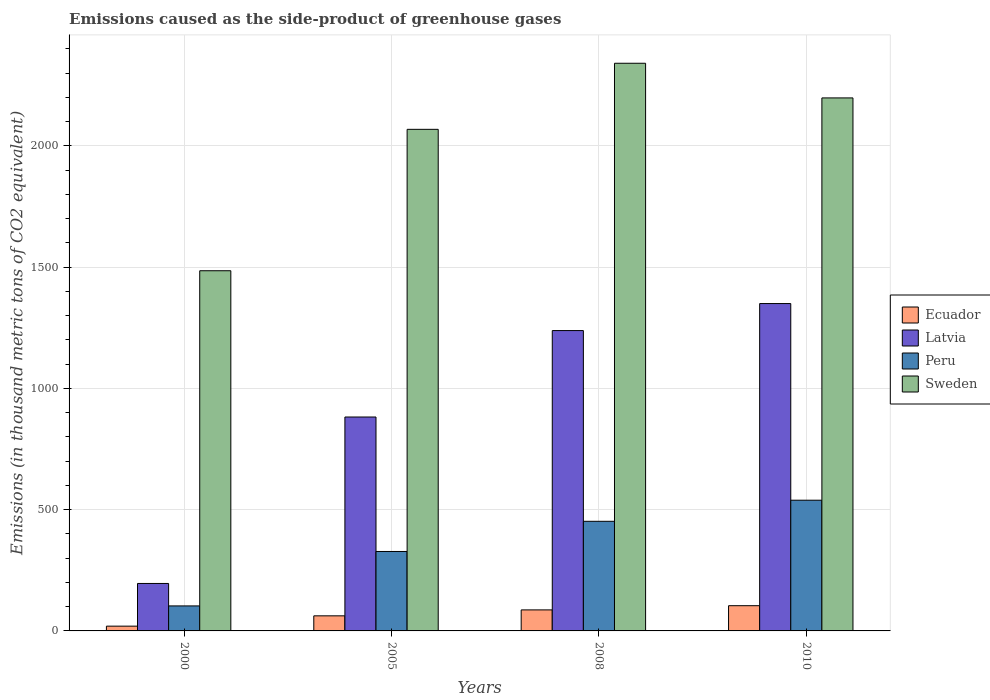How many groups of bars are there?
Make the answer very short. 4. How many bars are there on the 1st tick from the left?
Your response must be concise. 4. How many bars are there on the 4th tick from the right?
Make the answer very short. 4. What is the emissions caused as the side-product of greenhouse gases in Sweden in 2000?
Keep it short and to the point. 1485.3. Across all years, what is the maximum emissions caused as the side-product of greenhouse gases in Ecuador?
Give a very brief answer. 104. In which year was the emissions caused as the side-product of greenhouse gases in Sweden maximum?
Your answer should be very brief. 2008. In which year was the emissions caused as the side-product of greenhouse gases in Latvia minimum?
Provide a succinct answer. 2000. What is the total emissions caused as the side-product of greenhouse gases in Ecuador in the graph?
Keep it short and to the point. 272.6. What is the difference between the emissions caused as the side-product of greenhouse gases in Ecuador in 2008 and that in 2010?
Provide a succinct answer. -17.3. What is the difference between the emissions caused as the side-product of greenhouse gases in Latvia in 2008 and the emissions caused as the side-product of greenhouse gases in Peru in 2010?
Ensure brevity in your answer.  699.6. What is the average emissions caused as the side-product of greenhouse gases in Latvia per year?
Provide a short and direct response. 916.6. In the year 2005, what is the difference between the emissions caused as the side-product of greenhouse gases in Ecuador and emissions caused as the side-product of greenhouse gases in Latvia?
Provide a short and direct response. -819.9. What is the ratio of the emissions caused as the side-product of greenhouse gases in Ecuador in 2000 to that in 2010?
Provide a short and direct response. 0.19. Is the emissions caused as the side-product of greenhouse gases in Sweden in 2000 less than that in 2010?
Provide a short and direct response. Yes. What is the difference between the highest and the second highest emissions caused as the side-product of greenhouse gases in Peru?
Offer a terse response. 87. What is the difference between the highest and the lowest emissions caused as the side-product of greenhouse gases in Sweden?
Your response must be concise. 855.6. What does the 1st bar from the left in 2008 represents?
Your answer should be compact. Ecuador. What does the 1st bar from the right in 2005 represents?
Offer a terse response. Sweden. How many bars are there?
Your answer should be very brief. 16. What is the difference between two consecutive major ticks on the Y-axis?
Offer a very short reply. 500. Does the graph contain any zero values?
Your answer should be compact. No. What is the title of the graph?
Your answer should be very brief. Emissions caused as the side-product of greenhouse gases. Does "Trinidad and Tobago" appear as one of the legend labels in the graph?
Your response must be concise. No. What is the label or title of the X-axis?
Offer a terse response. Years. What is the label or title of the Y-axis?
Give a very brief answer. Emissions (in thousand metric tons of CO2 equivalent). What is the Emissions (in thousand metric tons of CO2 equivalent) in Latvia in 2000?
Offer a very short reply. 195.7. What is the Emissions (in thousand metric tons of CO2 equivalent) of Peru in 2000?
Ensure brevity in your answer.  103.1. What is the Emissions (in thousand metric tons of CO2 equivalent) of Sweden in 2000?
Keep it short and to the point. 1485.3. What is the Emissions (in thousand metric tons of CO2 equivalent) of Ecuador in 2005?
Your answer should be very brief. 62.2. What is the Emissions (in thousand metric tons of CO2 equivalent) of Latvia in 2005?
Offer a very short reply. 882.1. What is the Emissions (in thousand metric tons of CO2 equivalent) in Peru in 2005?
Give a very brief answer. 327.6. What is the Emissions (in thousand metric tons of CO2 equivalent) of Sweden in 2005?
Make the answer very short. 2068.4. What is the Emissions (in thousand metric tons of CO2 equivalent) of Ecuador in 2008?
Make the answer very short. 86.7. What is the Emissions (in thousand metric tons of CO2 equivalent) of Latvia in 2008?
Ensure brevity in your answer.  1238.6. What is the Emissions (in thousand metric tons of CO2 equivalent) in Peru in 2008?
Keep it short and to the point. 452. What is the Emissions (in thousand metric tons of CO2 equivalent) in Sweden in 2008?
Make the answer very short. 2340.9. What is the Emissions (in thousand metric tons of CO2 equivalent) in Ecuador in 2010?
Your answer should be compact. 104. What is the Emissions (in thousand metric tons of CO2 equivalent) of Latvia in 2010?
Offer a terse response. 1350. What is the Emissions (in thousand metric tons of CO2 equivalent) of Peru in 2010?
Your answer should be compact. 539. What is the Emissions (in thousand metric tons of CO2 equivalent) in Sweden in 2010?
Provide a short and direct response. 2198. Across all years, what is the maximum Emissions (in thousand metric tons of CO2 equivalent) of Ecuador?
Your answer should be very brief. 104. Across all years, what is the maximum Emissions (in thousand metric tons of CO2 equivalent) in Latvia?
Ensure brevity in your answer.  1350. Across all years, what is the maximum Emissions (in thousand metric tons of CO2 equivalent) in Peru?
Offer a very short reply. 539. Across all years, what is the maximum Emissions (in thousand metric tons of CO2 equivalent) of Sweden?
Ensure brevity in your answer.  2340.9. Across all years, what is the minimum Emissions (in thousand metric tons of CO2 equivalent) in Ecuador?
Your response must be concise. 19.7. Across all years, what is the minimum Emissions (in thousand metric tons of CO2 equivalent) in Latvia?
Keep it short and to the point. 195.7. Across all years, what is the minimum Emissions (in thousand metric tons of CO2 equivalent) of Peru?
Provide a succinct answer. 103.1. Across all years, what is the minimum Emissions (in thousand metric tons of CO2 equivalent) in Sweden?
Provide a succinct answer. 1485.3. What is the total Emissions (in thousand metric tons of CO2 equivalent) in Ecuador in the graph?
Offer a very short reply. 272.6. What is the total Emissions (in thousand metric tons of CO2 equivalent) in Latvia in the graph?
Give a very brief answer. 3666.4. What is the total Emissions (in thousand metric tons of CO2 equivalent) of Peru in the graph?
Offer a very short reply. 1421.7. What is the total Emissions (in thousand metric tons of CO2 equivalent) in Sweden in the graph?
Ensure brevity in your answer.  8092.6. What is the difference between the Emissions (in thousand metric tons of CO2 equivalent) in Ecuador in 2000 and that in 2005?
Keep it short and to the point. -42.5. What is the difference between the Emissions (in thousand metric tons of CO2 equivalent) in Latvia in 2000 and that in 2005?
Offer a terse response. -686.4. What is the difference between the Emissions (in thousand metric tons of CO2 equivalent) of Peru in 2000 and that in 2005?
Offer a terse response. -224.5. What is the difference between the Emissions (in thousand metric tons of CO2 equivalent) of Sweden in 2000 and that in 2005?
Provide a succinct answer. -583.1. What is the difference between the Emissions (in thousand metric tons of CO2 equivalent) of Ecuador in 2000 and that in 2008?
Ensure brevity in your answer.  -67. What is the difference between the Emissions (in thousand metric tons of CO2 equivalent) of Latvia in 2000 and that in 2008?
Offer a terse response. -1042.9. What is the difference between the Emissions (in thousand metric tons of CO2 equivalent) of Peru in 2000 and that in 2008?
Your response must be concise. -348.9. What is the difference between the Emissions (in thousand metric tons of CO2 equivalent) in Sweden in 2000 and that in 2008?
Your answer should be very brief. -855.6. What is the difference between the Emissions (in thousand metric tons of CO2 equivalent) of Ecuador in 2000 and that in 2010?
Offer a terse response. -84.3. What is the difference between the Emissions (in thousand metric tons of CO2 equivalent) in Latvia in 2000 and that in 2010?
Make the answer very short. -1154.3. What is the difference between the Emissions (in thousand metric tons of CO2 equivalent) in Peru in 2000 and that in 2010?
Ensure brevity in your answer.  -435.9. What is the difference between the Emissions (in thousand metric tons of CO2 equivalent) of Sweden in 2000 and that in 2010?
Ensure brevity in your answer.  -712.7. What is the difference between the Emissions (in thousand metric tons of CO2 equivalent) in Ecuador in 2005 and that in 2008?
Give a very brief answer. -24.5. What is the difference between the Emissions (in thousand metric tons of CO2 equivalent) in Latvia in 2005 and that in 2008?
Provide a succinct answer. -356.5. What is the difference between the Emissions (in thousand metric tons of CO2 equivalent) of Peru in 2005 and that in 2008?
Keep it short and to the point. -124.4. What is the difference between the Emissions (in thousand metric tons of CO2 equivalent) in Sweden in 2005 and that in 2008?
Make the answer very short. -272.5. What is the difference between the Emissions (in thousand metric tons of CO2 equivalent) of Ecuador in 2005 and that in 2010?
Provide a short and direct response. -41.8. What is the difference between the Emissions (in thousand metric tons of CO2 equivalent) of Latvia in 2005 and that in 2010?
Give a very brief answer. -467.9. What is the difference between the Emissions (in thousand metric tons of CO2 equivalent) of Peru in 2005 and that in 2010?
Keep it short and to the point. -211.4. What is the difference between the Emissions (in thousand metric tons of CO2 equivalent) in Sweden in 2005 and that in 2010?
Ensure brevity in your answer.  -129.6. What is the difference between the Emissions (in thousand metric tons of CO2 equivalent) in Ecuador in 2008 and that in 2010?
Offer a very short reply. -17.3. What is the difference between the Emissions (in thousand metric tons of CO2 equivalent) in Latvia in 2008 and that in 2010?
Offer a very short reply. -111.4. What is the difference between the Emissions (in thousand metric tons of CO2 equivalent) of Peru in 2008 and that in 2010?
Keep it short and to the point. -87. What is the difference between the Emissions (in thousand metric tons of CO2 equivalent) in Sweden in 2008 and that in 2010?
Keep it short and to the point. 142.9. What is the difference between the Emissions (in thousand metric tons of CO2 equivalent) in Ecuador in 2000 and the Emissions (in thousand metric tons of CO2 equivalent) in Latvia in 2005?
Your answer should be very brief. -862.4. What is the difference between the Emissions (in thousand metric tons of CO2 equivalent) of Ecuador in 2000 and the Emissions (in thousand metric tons of CO2 equivalent) of Peru in 2005?
Keep it short and to the point. -307.9. What is the difference between the Emissions (in thousand metric tons of CO2 equivalent) in Ecuador in 2000 and the Emissions (in thousand metric tons of CO2 equivalent) in Sweden in 2005?
Give a very brief answer. -2048.7. What is the difference between the Emissions (in thousand metric tons of CO2 equivalent) of Latvia in 2000 and the Emissions (in thousand metric tons of CO2 equivalent) of Peru in 2005?
Ensure brevity in your answer.  -131.9. What is the difference between the Emissions (in thousand metric tons of CO2 equivalent) of Latvia in 2000 and the Emissions (in thousand metric tons of CO2 equivalent) of Sweden in 2005?
Offer a very short reply. -1872.7. What is the difference between the Emissions (in thousand metric tons of CO2 equivalent) of Peru in 2000 and the Emissions (in thousand metric tons of CO2 equivalent) of Sweden in 2005?
Provide a succinct answer. -1965.3. What is the difference between the Emissions (in thousand metric tons of CO2 equivalent) in Ecuador in 2000 and the Emissions (in thousand metric tons of CO2 equivalent) in Latvia in 2008?
Your response must be concise. -1218.9. What is the difference between the Emissions (in thousand metric tons of CO2 equivalent) of Ecuador in 2000 and the Emissions (in thousand metric tons of CO2 equivalent) of Peru in 2008?
Provide a succinct answer. -432.3. What is the difference between the Emissions (in thousand metric tons of CO2 equivalent) in Ecuador in 2000 and the Emissions (in thousand metric tons of CO2 equivalent) in Sweden in 2008?
Provide a short and direct response. -2321.2. What is the difference between the Emissions (in thousand metric tons of CO2 equivalent) of Latvia in 2000 and the Emissions (in thousand metric tons of CO2 equivalent) of Peru in 2008?
Offer a terse response. -256.3. What is the difference between the Emissions (in thousand metric tons of CO2 equivalent) in Latvia in 2000 and the Emissions (in thousand metric tons of CO2 equivalent) in Sweden in 2008?
Keep it short and to the point. -2145.2. What is the difference between the Emissions (in thousand metric tons of CO2 equivalent) in Peru in 2000 and the Emissions (in thousand metric tons of CO2 equivalent) in Sweden in 2008?
Provide a succinct answer. -2237.8. What is the difference between the Emissions (in thousand metric tons of CO2 equivalent) in Ecuador in 2000 and the Emissions (in thousand metric tons of CO2 equivalent) in Latvia in 2010?
Your answer should be very brief. -1330.3. What is the difference between the Emissions (in thousand metric tons of CO2 equivalent) of Ecuador in 2000 and the Emissions (in thousand metric tons of CO2 equivalent) of Peru in 2010?
Give a very brief answer. -519.3. What is the difference between the Emissions (in thousand metric tons of CO2 equivalent) of Ecuador in 2000 and the Emissions (in thousand metric tons of CO2 equivalent) of Sweden in 2010?
Give a very brief answer. -2178.3. What is the difference between the Emissions (in thousand metric tons of CO2 equivalent) in Latvia in 2000 and the Emissions (in thousand metric tons of CO2 equivalent) in Peru in 2010?
Your answer should be very brief. -343.3. What is the difference between the Emissions (in thousand metric tons of CO2 equivalent) in Latvia in 2000 and the Emissions (in thousand metric tons of CO2 equivalent) in Sweden in 2010?
Keep it short and to the point. -2002.3. What is the difference between the Emissions (in thousand metric tons of CO2 equivalent) in Peru in 2000 and the Emissions (in thousand metric tons of CO2 equivalent) in Sweden in 2010?
Provide a succinct answer. -2094.9. What is the difference between the Emissions (in thousand metric tons of CO2 equivalent) of Ecuador in 2005 and the Emissions (in thousand metric tons of CO2 equivalent) of Latvia in 2008?
Your response must be concise. -1176.4. What is the difference between the Emissions (in thousand metric tons of CO2 equivalent) in Ecuador in 2005 and the Emissions (in thousand metric tons of CO2 equivalent) in Peru in 2008?
Your answer should be very brief. -389.8. What is the difference between the Emissions (in thousand metric tons of CO2 equivalent) of Ecuador in 2005 and the Emissions (in thousand metric tons of CO2 equivalent) of Sweden in 2008?
Offer a very short reply. -2278.7. What is the difference between the Emissions (in thousand metric tons of CO2 equivalent) of Latvia in 2005 and the Emissions (in thousand metric tons of CO2 equivalent) of Peru in 2008?
Provide a succinct answer. 430.1. What is the difference between the Emissions (in thousand metric tons of CO2 equivalent) in Latvia in 2005 and the Emissions (in thousand metric tons of CO2 equivalent) in Sweden in 2008?
Your response must be concise. -1458.8. What is the difference between the Emissions (in thousand metric tons of CO2 equivalent) in Peru in 2005 and the Emissions (in thousand metric tons of CO2 equivalent) in Sweden in 2008?
Give a very brief answer. -2013.3. What is the difference between the Emissions (in thousand metric tons of CO2 equivalent) in Ecuador in 2005 and the Emissions (in thousand metric tons of CO2 equivalent) in Latvia in 2010?
Keep it short and to the point. -1287.8. What is the difference between the Emissions (in thousand metric tons of CO2 equivalent) of Ecuador in 2005 and the Emissions (in thousand metric tons of CO2 equivalent) of Peru in 2010?
Provide a succinct answer. -476.8. What is the difference between the Emissions (in thousand metric tons of CO2 equivalent) in Ecuador in 2005 and the Emissions (in thousand metric tons of CO2 equivalent) in Sweden in 2010?
Your answer should be very brief. -2135.8. What is the difference between the Emissions (in thousand metric tons of CO2 equivalent) in Latvia in 2005 and the Emissions (in thousand metric tons of CO2 equivalent) in Peru in 2010?
Keep it short and to the point. 343.1. What is the difference between the Emissions (in thousand metric tons of CO2 equivalent) in Latvia in 2005 and the Emissions (in thousand metric tons of CO2 equivalent) in Sweden in 2010?
Your answer should be very brief. -1315.9. What is the difference between the Emissions (in thousand metric tons of CO2 equivalent) in Peru in 2005 and the Emissions (in thousand metric tons of CO2 equivalent) in Sweden in 2010?
Your answer should be compact. -1870.4. What is the difference between the Emissions (in thousand metric tons of CO2 equivalent) of Ecuador in 2008 and the Emissions (in thousand metric tons of CO2 equivalent) of Latvia in 2010?
Offer a very short reply. -1263.3. What is the difference between the Emissions (in thousand metric tons of CO2 equivalent) in Ecuador in 2008 and the Emissions (in thousand metric tons of CO2 equivalent) in Peru in 2010?
Ensure brevity in your answer.  -452.3. What is the difference between the Emissions (in thousand metric tons of CO2 equivalent) in Ecuador in 2008 and the Emissions (in thousand metric tons of CO2 equivalent) in Sweden in 2010?
Your answer should be very brief. -2111.3. What is the difference between the Emissions (in thousand metric tons of CO2 equivalent) of Latvia in 2008 and the Emissions (in thousand metric tons of CO2 equivalent) of Peru in 2010?
Keep it short and to the point. 699.6. What is the difference between the Emissions (in thousand metric tons of CO2 equivalent) in Latvia in 2008 and the Emissions (in thousand metric tons of CO2 equivalent) in Sweden in 2010?
Offer a very short reply. -959.4. What is the difference between the Emissions (in thousand metric tons of CO2 equivalent) of Peru in 2008 and the Emissions (in thousand metric tons of CO2 equivalent) of Sweden in 2010?
Your response must be concise. -1746. What is the average Emissions (in thousand metric tons of CO2 equivalent) in Ecuador per year?
Give a very brief answer. 68.15. What is the average Emissions (in thousand metric tons of CO2 equivalent) of Latvia per year?
Ensure brevity in your answer.  916.6. What is the average Emissions (in thousand metric tons of CO2 equivalent) in Peru per year?
Provide a short and direct response. 355.43. What is the average Emissions (in thousand metric tons of CO2 equivalent) of Sweden per year?
Ensure brevity in your answer.  2023.15. In the year 2000, what is the difference between the Emissions (in thousand metric tons of CO2 equivalent) of Ecuador and Emissions (in thousand metric tons of CO2 equivalent) of Latvia?
Provide a succinct answer. -176. In the year 2000, what is the difference between the Emissions (in thousand metric tons of CO2 equivalent) of Ecuador and Emissions (in thousand metric tons of CO2 equivalent) of Peru?
Your answer should be compact. -83.4. In the year 2000, what is the difference between the Emissions (in thousand metric tons of CO2 equivalent) of Ecuador and Emissions (in thousand metric tons of CO2 equivalent) of Sweden?
Your answer should be compact. -1465.6. In the year 2000, what is the difference between the Emissions (in thousand metric tons of CO2 equivalent) in Latvia and Emissions (in thousand metric tons of CO2 equivalent) in Peru?
Your answer should be very brief. 92.6. In the year 2000, what is the difference between the Emissions (in thousand metric tons of CO2 equivalent) of Latvia and Emissions (in thousand metric tons of CO2 equivalent) of Sweden?
Make the answer very short. -1289.6. In the year 2000, what is the difference between the Emissions (in thousand metric tons of CO2 equivalent) in Peru and Emissions (in thousand metric tons of CO2 equivalent) in Sweden?
Make the answer very short. -1382.2. In the year 2005, what is the difference between the Emissions (in thousand metric tons of CO2 equivalent) in Ecuador and Emissions (in thousand metric tons of CO2 equivalent) in Latvia?
Offer a terse response. -819.9. In the year 2005, what is the difference between the Emissions (in thousand metric tons of CO2 equivalent) in Ecuador and Emissions (in thousand metric tons of CO2 equivalent) in Peru?
Make the answer very short. -265.4. In the year 2005, what is the difference between the Emissions (in thousand metric tons of CO2 equivalent) in Ecuador and Emissions (in thousand metric tons of CO2 equivalent) in Sweden?
Your answer should be compact. -2006.2. In the year 2005, what is the difference between the Emissions (in thousand metric tons of CO2 equivalent) of Latvia and Emissions (in thousand metric tons of CO2 equivalent) of Peru?
Your response must be concise. 554.5. In the year 2005, what is the difference between the Emissions (in thousand metric tons of CO2 equivalent) in Latvia and Emissions (in thousand metric tons of CO2 equivalent) in Sweden?
Make the answer very short. -1186.3. In the year 2005, what is the difference between the Emissions (in thousand metric tons of CO2 equivalent) of Peru and Emissions (in thousand metric tons of CO2 equivalent) of Sweden?
Provide a succinct answer. -1740.8. In the year 2008, what is the difference between the Emissions (in thousand metric tons of CO2 equivalent) in Ecuador and Emissions (in thousand metric tons of CO2 equivalent) in Latvia?
Offer a very short reply. -1151.9. In the year 2008, what is the difference between the Emissions (in thousand metric tons of CO2 equivalent) of Ecuador and Emissions (in thousand metric tons of CO2 equivalent) of Peru?
Your answer should be very brief. -365.3. In the year 2008, what is the difference between the Emissions (in thousand metric tons of CO2 equivalent) of Ecuador and Emissions (in thousand metric tons of CO2 equivalent) of Sweden?
Ensure brevity in your answer.  -2254.2. In the year 2008, what is the difference between the Emissions (in thousand metric tons of CO2 equivalent) in Latvia and Emissions (in thousand metric tons of CO2 equivalent) in Peru?
Provide a succinct answer. 786.6. In the year 2008, what is the difference between the Emissions (in thousand metric tons of CO2 equivalent) of Latvia and Emissions (in thousand metric tons of CO2 equivalent) of Sweden?
Provide a short and direct response. -1102.3. In the year 2008, what is the difference between the Emissions (in thousand metric tons of CO2 equivalent) of Peru and Emissions (in thousand metric tons of CO2 equivalent) of Sweden?
Provide a succinct answer. -1888.9. In the year 2010, what is the difference between the Emissions (in thousand metric tons of CO2 equivalent) of Ecuador and Emissions (in thousand metric tons of CO2 equivalent) of Latvia?
Your answer should be compact. -1246. In the year 2010, what is the difference between the Emissions (in thousand metric tons of CO2 equivalent) of Ecuador and Emissions (in thousand metric tons of CO2 equivalent) of Peru?
Your answer should be very brief. -435. In the year 2010, what is the difference between the Emissions (in thousand metric tons of CO2 equivalent) in Ecuador and Emissions (in thousand metric tons of CO2 equivalent) in Sweden?
Offer a terse response. -2094. In the year 2010, what is the difference between the Emissions (in thousand metric tons of CO2 equivalent) in Latvia and Emissions (in thousand metric tons of CO2 equivalent) in Peru?
Your response must be concise. 811. In the year 2010, what is the difference between the Emissions (in thousand metric tons of CO2 equivalent) of Latvia and Emissions (in thousand metric tons of CO2 equivalent) of Sweden?
Your answer should be very brief. -848. In the year 2010, what is the difference between the Emissions (in thousand metric tons of CO2 equivalent) of Peru and Emissions (in thousand metric tons of CO2 equivalent) of Sweden?
Offer a terse response. -1659. What is the ratio of the Emissions (in thousand metric tons of CO2 equivalent) of Ecuador in 2000 to that in 2005?
Provide a short and direct response. 0.32. What is the ratio of the Emissions (in thousand metric tons of CO2 equivalent) in Latvia in 2000 to that in 2005?
Ensure brevity in your answer.  0.22. What is the ratio of the Emissions (in thousand metric tons of CO2 equivalent) of Peru in 2000 to that in 2005?
Provide a short and direct response. 0.31. What is the ratio of the Emissions (in thousand metric tons of CO2 equivalent) of Sweden in 2000 to that in 2005?
Provide a succinct answer. 0.72. What is the ratio of the Emissions (in thousand metric tons of CO2 equivalent) of Ecuador in 2000 to that in 2008?
Ensure brevity in your answer.  0.23. What is the ratio of the Emissions (in thousand metric tons of CO2 equivalent) in Latvia in 2000 to that in 2008?
Give a very brief answer. 0.16. What is the ratio of the Emissions (in thousand metric tons of CO2 equivalent) of Peru in 2000 to that in 2008?
Provide a short and direct response. 0.23. What is the ratio of the Emissions (in thousand metric tons of CO2 equivalent) in Sweden in 2000 to that in 2008?
Your answer should be very brief. 0.63. What is the ratio of the Emissions (in thousand metric tons of CO2 equivalent) of Ecuador in 2000 to that in 2010?
Offer a terse response. 0.19. What is the ratio of the Emissions (in thousand metric tons of CO2 equivalent) in Latvia in 2000 to that in 2010?
Keep it short and to the point. 0.14. What is the ratio of the Emissions (in thousand metric tons of CO2 equivalent) in Peru in 2000 to that in 2010?
Provide a succinct answer. 0.19. What is the ratio of the Emissions (in thousand metric tons of CO2 equivalent) of Sweden in 2000 to that in 2010?
Keep it short and to the point. 0.68. What is the ratio of the Emissions (in thousand metric tons of CO2 equivalent) of Ecuador in 2005 to that in 2008?
Offer a terse response. 0.72. What is the ratio of the Emissions (in thousand metric tons of CO2 equivalent) of Latvia in 2005 to that in 2008?
Ensure brevity in your answer.  0.71. What is the ratio of the Emissions (in thousand metric tons of CO2 equivalent) of Peru in 2005 to that in 2008?
Your answer should be compact. 0.72. What is the ratio of the Emissions (in thousand metric tons of CO2 equivalent) of Sweden in 2005 to that in 2008?
Provide a succinct answer. 0.88. What is the ratio of the Emissions (in thousand metric tons of CO2 equivalent) in Ecuador in 2005 to that in 2010?
Provide a short and direct response. 0.6. What is the ratio of the Emissions (in thousand metric tons of CO2 equivalent) in Latvia in 2005 to that in 2010?
Your answer should be compact. 0.65. What is the ratio of the Emissions (in thousand metric tons of CO2 equivalent) in Peru in 2005 to that in 2010?
Ensure brevity in your answer.  0.61. What is the ratio of the Emissions (in thousand metric tons of CO2 equivalent) of Sweden in 2005 to that in 2010?
Provide a short and direct response. 0.94. What is the ratio of the Emissions (in thousand metric tons of CO2 equivalent) in Ecuador in 2008 to that in 2010?
Make the answer very short. 0.83. What is the ratio of the Emissions (in thousand metric tons of CO2 equivalent) in Latvia in 2008 to that in 2010?
Keep it short and to the point. 0.92. What is the ratio of the Emissions (in thousand metric tons of CO2 equivalent) of Peru in 2008 to that in 2010?
Offer a very short reply. 0.84. What is the ratio of the Emissions (in thousand metric tons of CO2 equivalent) in Sweden in 2008 to that in 2010?
Provide a short and direct response. 1.06. What is the difference between the highest and the second highest Emissions (in thousand metric tons of CO2 equivalent) in Ecuador?
Offer a very short reply. 17.3. What is the difference between the highest and the second highest Emissions (in thousand metric tons of CO2 equivalent) of Latvia?
Ensure brevity in your answer.  111.4. What is the difference between the highest and the second highest Emissions (in thousand metric tons of CO2 equivalent) of Sweden?
Provide a short and direct response. 142.9. What is the difference between the highest and the lowest Emissions (in thousand metric tons of CO2 equivalent) of Ecuador?
Your answer should be very brief. 84.3. What is the difference between the highest and the lowest Emissions (in thousand metric tons of CO2 equivalent) in Latvia?
Your response must be concise. 1154.3. What is the difference between the highest and the lowest Emissions (in thousand metric tons of CO2 equivalent) of Peru?
Provide a short and direct response. 435.9. What is the difference between the highest and the lowest Emissions (in thousand metric tons of CO2 equivalent) of Sweden?
Provide a short and direct response. 855.6. 